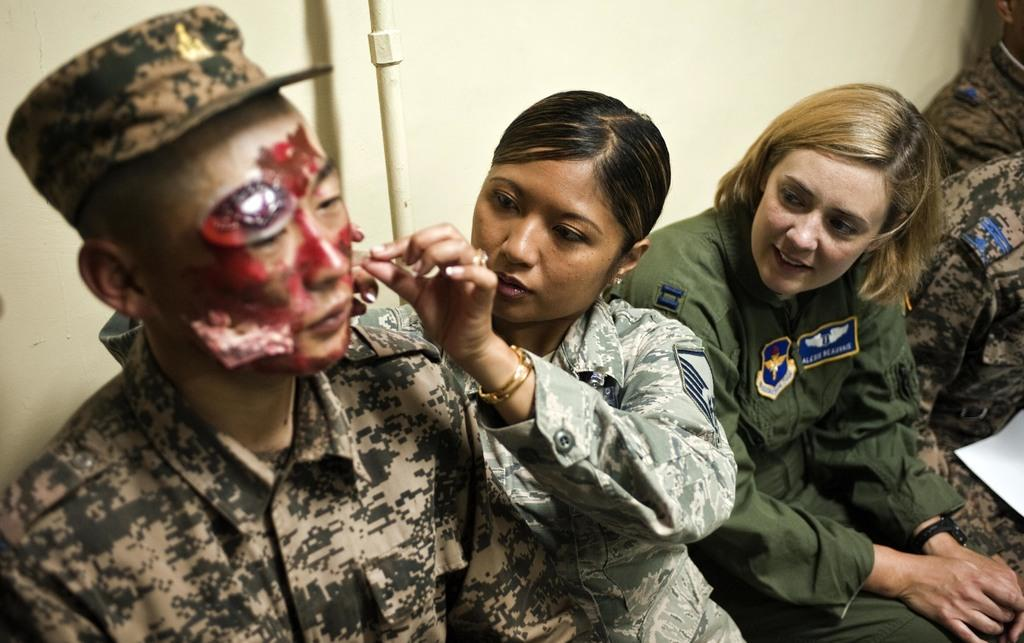What is the main subject of the image? The main subject of the image is a group of people. What are the people in the image doing? The people are sitting together. Can you describe any specific details about one of the individuals in the group? One of the men in the group has wounds on his face. What type of slip can be seen on the floor in the image? There is no slip visible on the floor in the image. What is the profit of the group in the image? The image does not provide any information about the group's profit. 